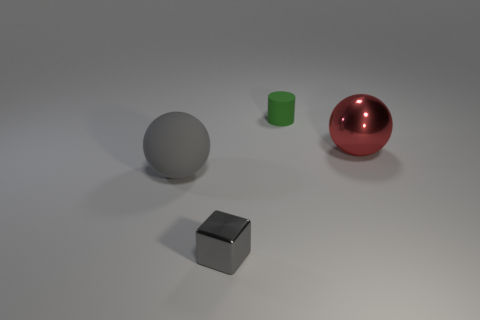Add 1 large red shiny things. How many objects exist? 5 Subtract all cubes. How many objects are left? 3 Add 4 large brown shiny balls. How many large brown shiny balls exist? 4 Subtract 1 green cylinders. How many objects are left? 3 Subtract all large things. Subtract all cylinders. How many objects are left? 1 Add 1 gray matte objects. How many gray matte objects are left? 2 